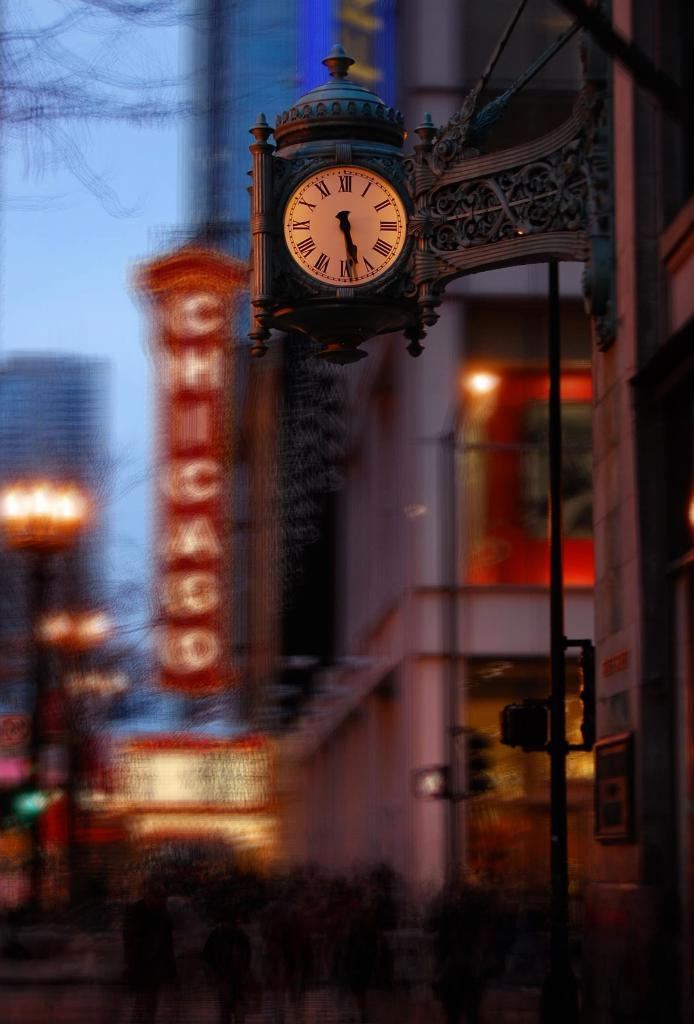<image>
Provide a brief description of the given image. A street view of a busy downtown area with people walking along the rows of stores in Chicago. 